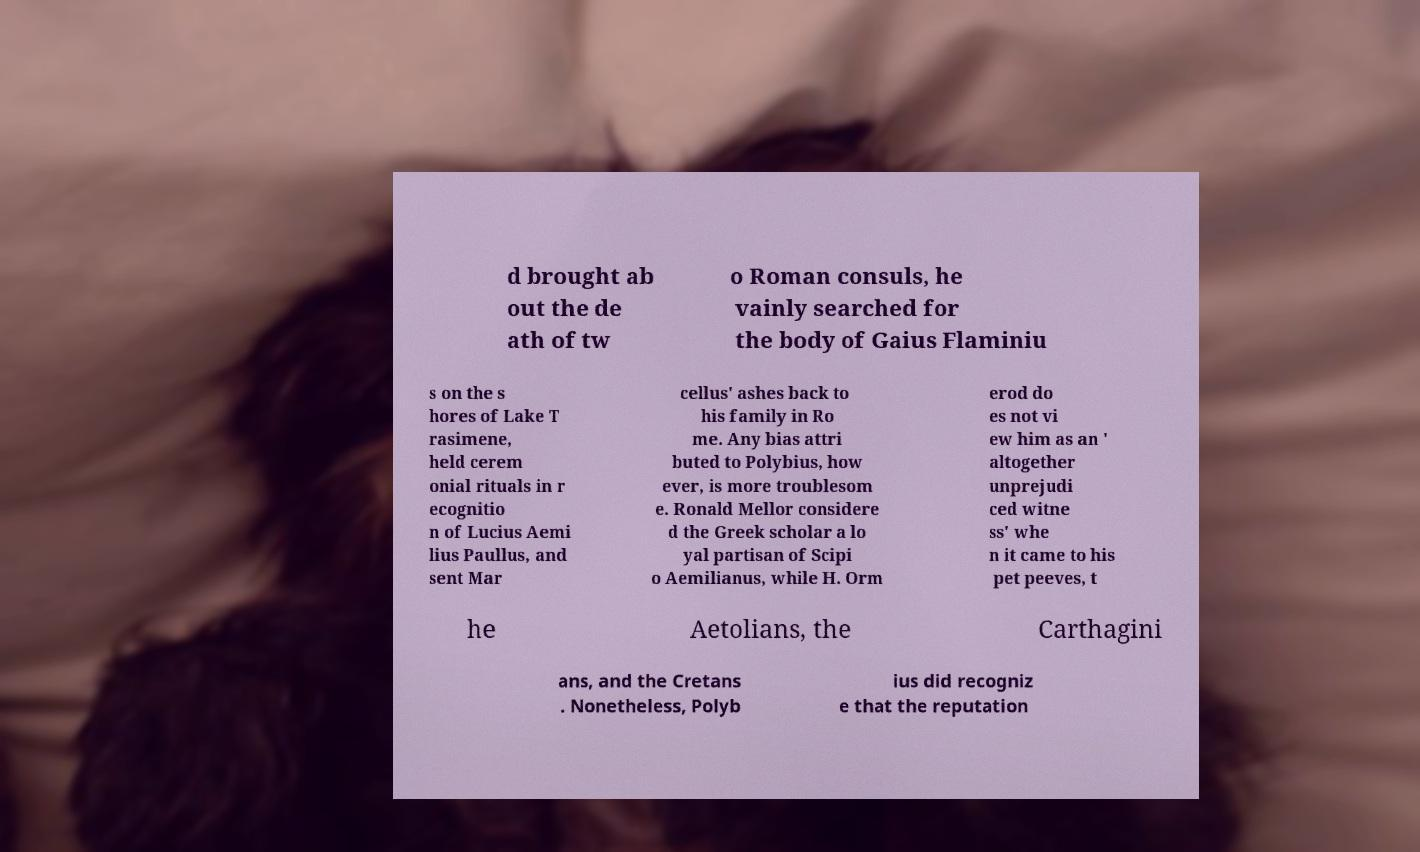Please read and relay the text visible in this image. What does it say? d brought ab out the de ath of tw o Roman consuls, he vainly searched for the body of Gaius Flaminiu s on the s hores of Lake T rasimene, held cerem onial rituals in r ecognitio n of Lucius Aemi lius Paullus, and sent Mar cellus' ashes back to his family in Ro me. Any bias attri buted to Polybius, how ever, is more troublesom e. Ronald Mellor considere d the Greek scholar a lo yal partisan of Scipi o Aemilianus, while H. Orm erod do es not vi ew him as an ' altogether unprejudi ced witne ss' whe n it came to his pet peeves, t he Aetolians, the Carthagini ans, and the Cretans . Nonetheless, Polyb ius did recogniz e that the reputation 